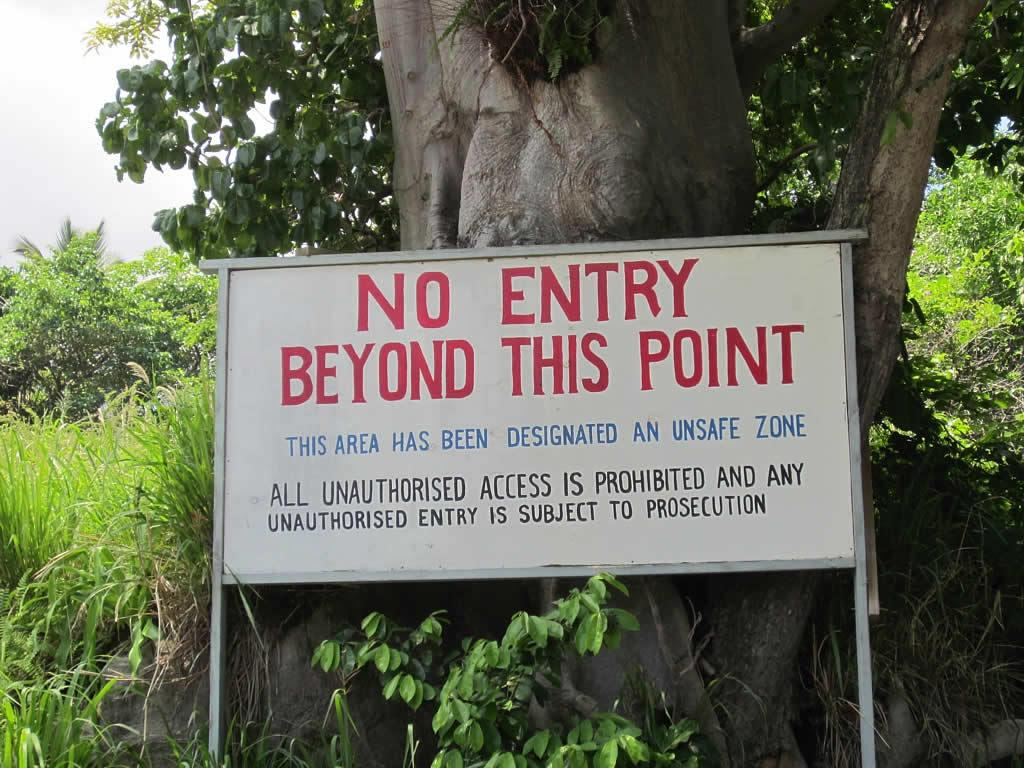What is the main object in the image? There is a name board in the image. What can be seen in the background of the image? There are trees and the sky visible in the background of the image. How many passengers are waiting in line for the shoe store in the image? There is no shoe store or passengers present in the image; it features a name board with trees and the sky in the background. 